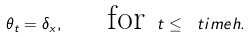Convert formula to latex. <formula><loc_0><loc_0><loc_500><loc_500>\theta _ { t } = \delta _ { x } , \text { \quad for } t \leq \ t i m e h .</formula> 